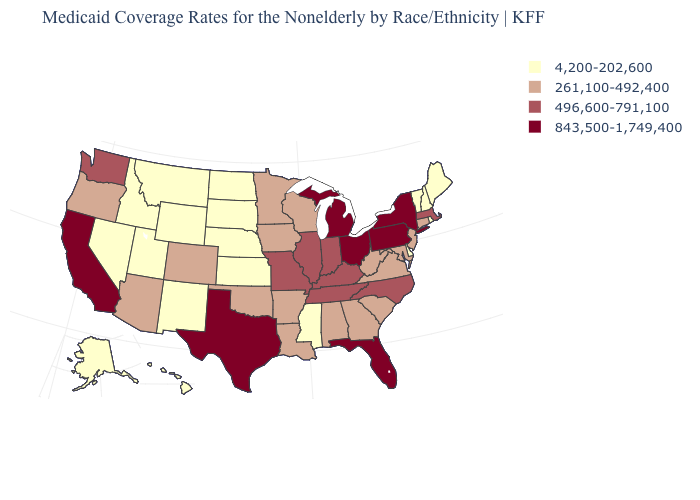Does Montana have the lowest value in the USA?
Give a very brief answer. Yes. What is the value of Alabama?
Answer briefly. 261,100-492,400. What is the lowest value in the USA?
Short answer required. 4,200-202,600. What is the highest value in the USA?
Short answer required. 843,500-1,749,400. What is the value of Iowa?
Answer briefly. 261,100-492,400. Does Alabama have the lowest value in the USA?
Give a very brief answer. No. Does Michigan have the highest value in the MidWest?
Answer briefly. Yes. Does Texas have the highest value in the South?
Concise answer only. Yes. Name the states that have a value in the range 843,500-1,749,400?
Short answer required. California, Florida, Michigan, New York, Ohio, Pennsylvania, Texas. What is the highest value in the USA?
Give a very brief answer. 843,500-1,749,400. Which states hav the highest value in the Northeast?
Concise answer only. New York, Pennsylvania. Does the map have missing data?
Keep it brief. No. Which states have the highest value in the USA?
Concise answer only. California, Florida, Michigan, New York, Ohio, Pennsylvania, Texas. How many symbols are there in the legend?
Answer briefly. 4. Among the states that border South Carolina , does Georgia have the highest value?
Short answer required. No. 